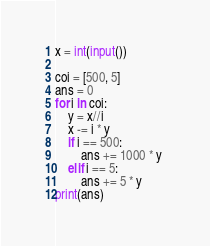Convert code to text. <code><loc_0><loc_0><loc_500><loc_500><_Python_>x = int(input())

coi = [500, 5]
ans = 0
for i in coi:
    y = x//i
    x -= i * y
    if i == 500:
        ans += 1000 * y 
    elif i == 5:
        ans += 5 * y
print(ans)</code> 